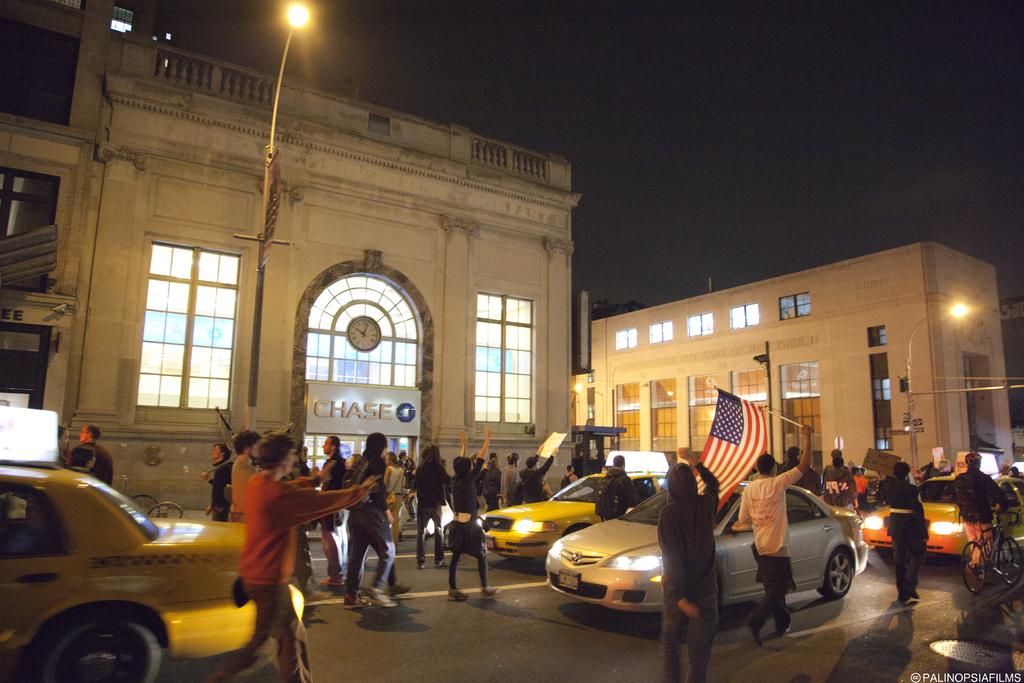What bank is this in the picture?
Offer a very short reply. Chase. What is the name of the bank?
Provide a succinct answer. Chase. 